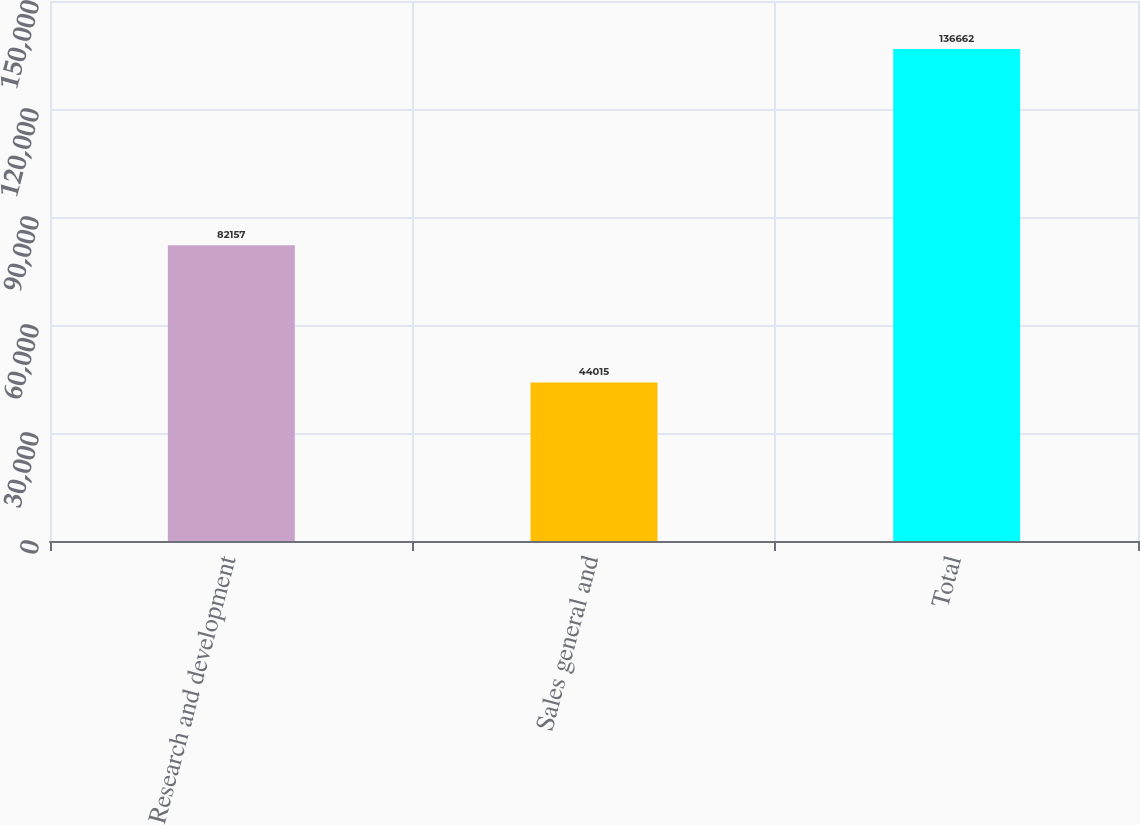Convert chart. <chart><loc_0><loc_0><loc_500><loc_500><bar_chart><fcel>Research and development<fcel>Sales general and<fcel>Total<nl><fcel>82157<fcel>44015<fcel>136662<nl></chart> 